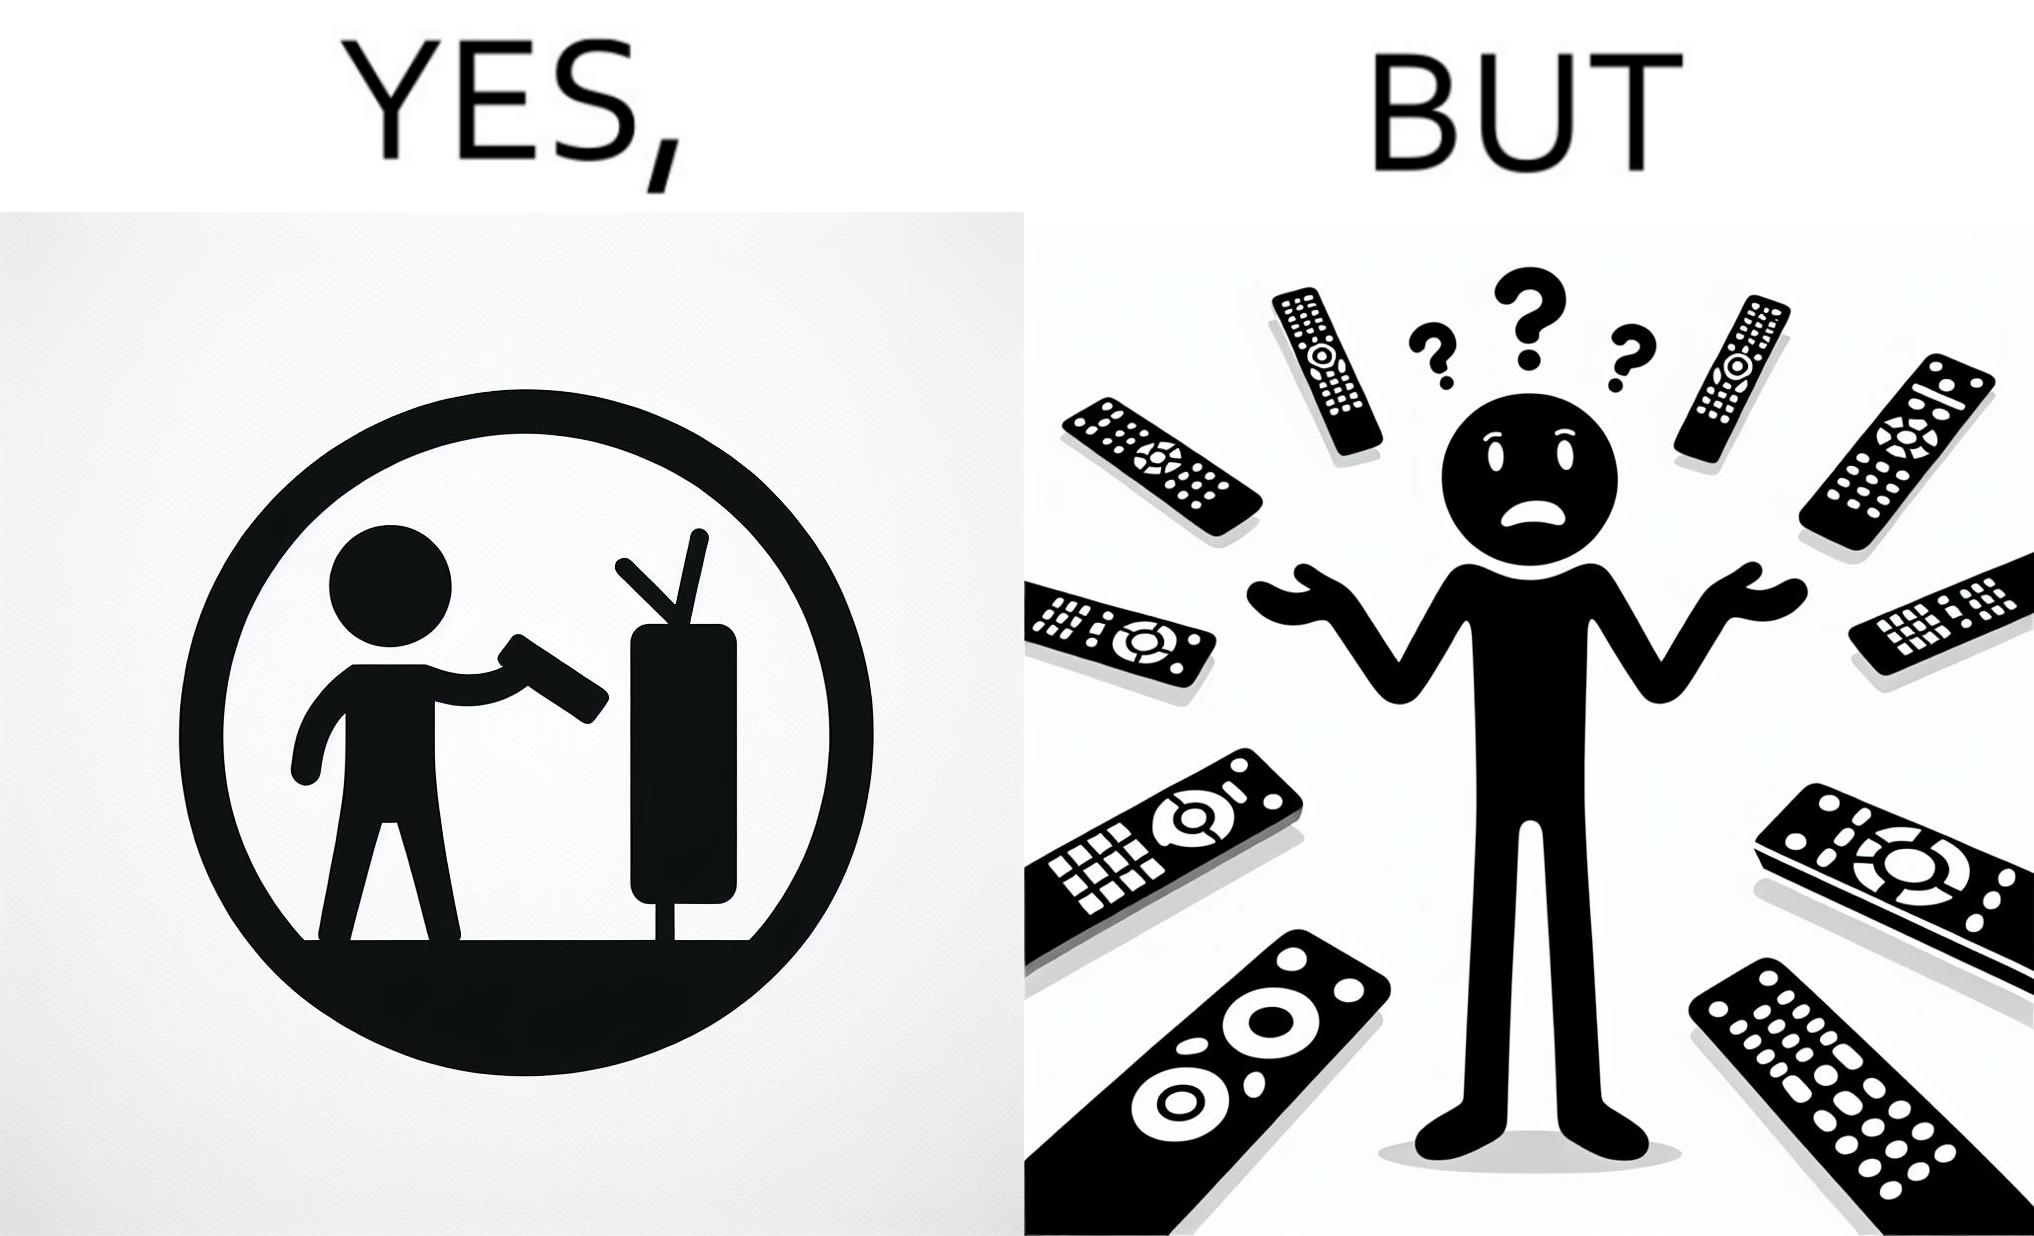What makes this image funny or satirical? The images are funny since they show how even though TV remotes are supposed to make operating TVs easier, having multiple similar looking remotes  for everything only makes it more difficult for the user to use the right one 